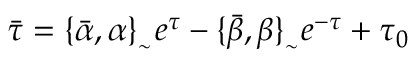Convert formula to latex. <formula><loc_0><loc_0><loc_500><loc_500>\bar { \tau } = \{ \bar { \alpha } , \alpha \} _ { _ { \sim } } e ^ { \tau } - \{ \bar { \beta } , \beta \} _ { _ { \sim } } e ^ { - \tau } + \tau _ { 0 }</formula> 